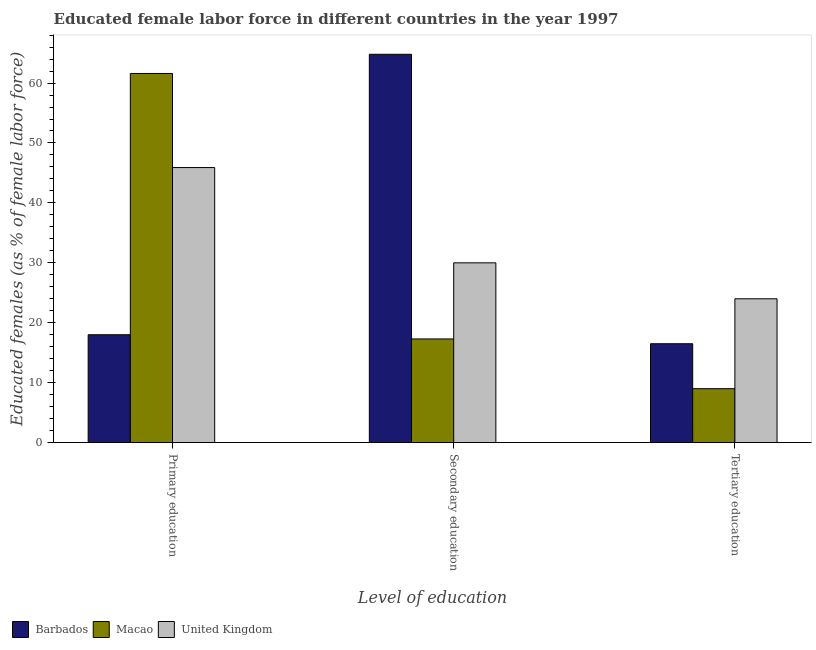How many different coloured bars are there?
Provide a succinct answer. 3. How many groups of bars are there?
Keep it short and to the point. 3. Are the number of bars per tick equal to the number of legend labels?
Offer a terse response. Yes. How many bars are there on the 3rd tick from the left?
Provide a short and direct response. 3. How many bars are there on the 3rd tick from the right?
Ensure brevity in your answer.  3. What is the label of the 3rd group of bars from the left?
Offer a terse response. Tertiary education. What is the percentage of female labor force who received secondary education in Macao?
Provide a succinct answer. 17.3. Across all countries, what is the maximum percentage of female labor force who received secondary education?
Your response must be concise. 64.8. Across all countries, what is the minimum percentage of female labor force who received secondary education?
Your answer should be very brief. 17.3. In which country was the percentage of female labor force who received secondary education maximum?
Give a very brief answer. Barbados. In which country was the percentage of female labor force who received primary education minimum?
Your answer should be compact. Barbados. What is the total percentage of female labor force who received tertiary education in the graph?
Your answer should be very brief. 49.5. What is the difference between the percentage of female labor force who received tertiary education in United Kingdom and that in Macao?
Ensure brevity in your answer.  15. What is the difference between the percentage of female labor force who received primary education in United Kingdom and the percentage of female labor force who received tertiary education in Macao?
Give a very brief answer. 36.9. What is the average percentage of female labor force who received tertiary education per country?
Provide a short and direct response. 16.5. What is the difference between the percentage of female labor force who received primary education and percentage of female labor force who received secondary education in Macao?
Your answer should be very brief. 44.3. What is the ratio of the percentage of female labor force who received secondary education in United Kingdom to that in Macao?
Offer a very short reply. 1.73. Is the difference between the percentage of female labor force who received secondary education in United Kingdom and Barbados greater than the difference between the percentage of female labor force who received tertiary education in United Kingdom and Barbados?
Give a very brief answer. No. What is the difference between the highest and the second highest percentage of female labor force who received secondary education?
Keep it short and to the point. 34.8. What is the difference between the highest and the lowest percentage of female labor force who received primary education?
Your answer should be compact. 43.6. In how many countries, is the percentage of female labor force who received primary education greater than the average percentage of female labor force who received primary education taken over all countries?
Ensure brevity in your answer.  2. What does the 3rd bar from the left in Tertiary education represents?
Ensure brevity in your answer.  United Kingdom. What does the 3rd bar from the right in Tertiary education represents?
Ensure brevity in your answer.  Barbados. How many countries are there in the graph?
Your answer should be compact. 3. What is the difference between two consecutive major ticks on the Y-axis?
Ensure brevity in your answer.  10. Does the graph contain grids?
Provide a succinct answer. No. Where does the legend appear in the graph?
Provide a short and direct response. Bottom left. How many legend labels are there?
Offer a terse response. 3. What is the title of the graph?
Make the answer very short. Educated female labor force in different countries in the year 1997. Does "Canada" appear as one of the legend labels in the graph?
Your answer should be compact. No. What is the label or title of the X-axis?
Your answer should be very brief. Level of education. What is the label or title of the Y-axis?
Keep it short and to the point. Educated females (as % of female labor force). What is the Educated females (as % of female labor force) in Macao in Primary education?
Keep it short and to the point. 61.6. What is the Educated females (as % of female labor force) of United Kingdom in Primary education?
Make the answer very short. 45.9. What is the Educated females (as % of female labor force) in Barbados in Secondary education?
Make the answer very short. 64.8. What is the Educated females (as % of female labor force) in Macao in Secondary education?
Ensure brevity in your answer.  17.3. What is the Educated females (as % of female labor force) in United Kingdom in Secondary education?
Give a very brief answer. 30. What is the Educated females (as % of female labor force) in Macao in Tertiary education?
Offer a terse response. 9. What is the Educated females (as % of female labor force) of United Kingdom in Tertiary education?
Provide a short and direct response. 24. Across all Level of education, what is the maximum Educated females (as % of female labor force) of Barbados?
Give a very brief answer. 64.8. Across all Level of education, what is the maximum Educated females (as % of female labor force) in Macao?
Keep it short and to the point. 61.6. Across all Level of education, what is the maximum Educated females (as % of female labor force) of United Kingdom?
Provide a succinct answer. 45.9. Across all Level of education, what is the minimum Educated females (as % of female labor force) of Barbados?
Give a very brief answer. 16.5. Across all Level of education, what is the minimum Educated females (as % of female labor force) of United Kingdom?
Your response must be concise. 24. What is the total Educated females (as % of female labor force) of Barbados in the graph?
Your answer should be compact. 99.3. What is the total Educated females (as % of female labor force) in Macao in the graph?
Your answer should be compact. 87.9. What is the total Educated females (as % of female labor force) of United Kingdom in the graph?
Your answer should be very brief. 99.9. What is the difference between the Educated females (as % of female labor force) of Barbados in Primary education and that in Secondary education?
Offer a very short reply. -46.8. What is the difference between the Educated females (as % of female labor force) in Macao in Primary education and that in Secondary education?
Provide a short and direct response. 44.3. What is the difference between the Educated females (as % of female labor force) in Macao in Primary education and that in Tertiary education?
Keep it short and to the point. 52.6. What is the difference between the Educated females (as % of female labor force) in United Kingdom in Primary education and that in Tertiary education?
Keep it short and to the point. 21.9. What is the difference between the Educated females (as % of female labor force) in Barbados in Secondary education and that in Tertiary education?
Ensure brevity in your answer.  48.3. What is the difference between the Educated females (as % of female labor force) in United Kingdom in Secondary education and that in Tertiary education?
Your answer should be very brief. 6. What is the difference between the Educated females (as % of female labor force) in Barbados in Primary education and the Educated females (as % of female labor force) in Macao in Secondary education?
Give a very brief answer. 0.7. What is the difference between the Educated females (as % of female labor force) of Barbados in Primary education and the Educated females (as % of female labor force) of United Kingdom in Secondary education?
Make the answer very short. -12. What is the difference between the Educated females (as % of female labor force) of Macao in Primary education and the Educated females (as % of female labor force) of United Kingdom in Secondary education?
Ensure brevity in your answer.  31.6. What is the difference between the Educated females (as % of female labor force) of Barbados in Primary education and the Educated females (as % of female labor force) of Macao in Tertiary education?
Give a very brief answer. 9. What is the difference between the Educated females (as % of female labor force) in Barbados in Primary education and the Educated females (as % of female labor force) in United Kingdom in Tertiary education?
Provide a succinct answer. -6. What is the difference between the Educated females (as % of female labor force) in Macao in Primary education and the Educated females (as % of female labor force) in United Kingdom in Tertiary education?
Give a very brief answer. 37.6. What is the difference between the Educated females (as % of female labor force) in Barbados in Secondary education and the Educated females (as % of female labor force) in Macao in Tertiary education?
Your answer should be very brief. 55.8. What is the difference between the Educated females (as % of female labor force) in Barbados in Secondary education and the Educated females (as % of female labor force) in United Kingdom in Tertiary education?
Your response must be concise. 40.8. What is the average Educated females (as % of female labor force) of Barbados per Level of education?
Provide a succinct answer. 33.1. What is the average Educated females (as % of female labor force) of Macao per Level of education?
Make the answer very short. 29.3. What is the average Educated females (as % of female labor force) of United Kingdom per Level of education?
Your answer should be very brief. 33.3. What is the difference between the Educated females (as % of female labor force) in Barbados and Educated females (as % of female labor force) in Macao in Primary education?
Keep it short and to the point. -43.6. What is the difference between the Educated females (as % of female labor force) in Barbados and Educated females (as % of female labor force) in United Kingdom in Primary education?
Make the answer very short. -27.9. What is the difference between the Educated females (as % of female labor force) in Barbados and Educated females (as % of female labor force) in Macao in Secondary education?
Ensure brevity in your answer.  47.5. What is the difference between the Educated females (as % of female labor force) in Barbados and Educated females (as % of female labor force) in United Kingdom in Secondary education?
Your response must be concise. 34.8. What is the difference between the Educated females (as % of female labor force) of Barbados and Educated females (as % of female labor force) of United Kingdom in Tertiary education?
Give a very brief answer. -7.5. What is the difference between the Educated females (as % of female labor force) of Macao and Educated females (as % of female labor force) of United Kingdom in Tertiary education?
Provide a short and direct response. -15. What is the ratio of the Educated females (as % of female labor force) of Barbados in Primary education to that in Secondary education?
Your response must be concise. 0.28. What is the ratio of the Educated females (as % of female labor force) of Macao in Primary education to that in Secondary education?
Make the answer very short. 3.56. What is the ratio of the Educated females (as % of female labor force) of United Kingdom in Primary education to that in Secondary education?
Offer a terse response. 1.53. What is the ratio of the Educated females (as % of female labor force) in Barbados in Primary education to that in Tertiary education?
Make the answer very short. 1.09. What is the ratio of the Educated females (as % of female labor force) in Macao in Primary education to that in Tertiary education?
Offer a terse response. 6.84. What is the ratio of the Educated females (as % of female labor force) of United Kingdom in Primary education to that in Tertiary education?
Provide a short and direct response. 1.91. What is the ratio of the Educated females (as % of female labor force) of Barbados in Secondary education to that in Tertiary education?
Offer a terse response. 3.93. What is the ratio of the Educated females (as % of female labor force) in Macao in Secondary education to that in Tertiary education?
Your answer should be very brief. 1.92. What is the difference between the highest and the second highest Educated females (as % of female labor force) of Barbados?
Ensure brevity in your answer.  46.8. What is the difference between the highest and the second highest Educated females (as % of female labor force) of Macao?
Provide a short and direct response. 44.3. What is the difference between the highest and the lowest Educated females (as % of female labor force) in Barbados?
Provide a succinct answer. 48.3. What is the difference between the highest and the lowest Educated females (as % of female labor force) of Macao?
Make the answer very short. 52.6. What is the difference between the highest and the lowest Educated females (as % of female labor force) in United Kingdom?
Offer a terse response. 21.9. 